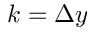Convert formula to latex. <formula><loc_0><loc_0><loc_500><loc_500>k = \Delta y</formula> 